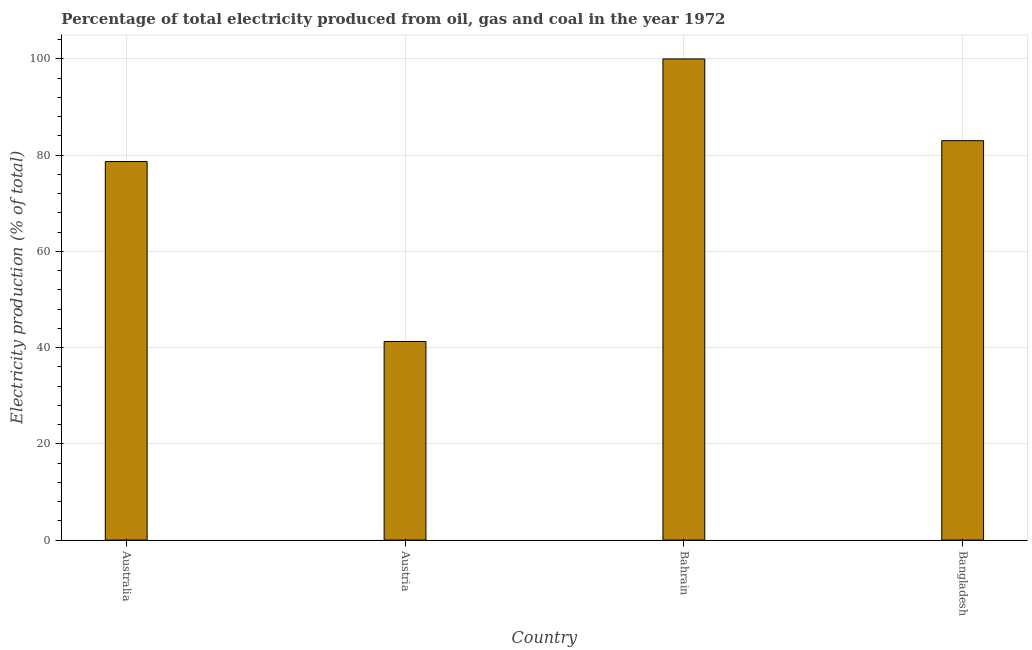Does the graph contain any zero values?
Offer a terse response. No. Does the graph contain grids?
Keep it short and to the point. Yes. What is the title of the graph?
Give a very brief answer. Percentage of total electricity produced from oil, gas and coal in the year 1972. What is the label or title of the X-axis?
Your answer should be compact. Country. What is the label or title of the Y-axis?
Offer a very short reply. Electricity production (% of total). What is the electricity production in Australia?
Keep it short and to the point. 78.68. Across all countries, what is the minimum electricity production?
Your response must be concise. 41.28. In which country was the electricity production maximum?
Offer a terse response. Bahrain. What is the sum of the electricity production?
Your answer should be compact. 302.96. What is the difference between the electricity production in Australia and Austria?
Keep it short and to the point. 37.4. What is the average electricity production per country?
Provide a succinct answer. 75.74. What is the median electricity production?
Ensure brevity in your answer.  80.84. In how many countries, is the electricity production greater than 96 %?
Keep it short and to the point. 1. What is the ratio of the electricity production in Austria to that in Bangladesh?
Offer a terse response. 0.5. What is the difference between the highest and the second highest electricity production?
Keep it short and to the point. 16.99. What is the difference between the highest and the lowest electricity production?
Your answer should be compact. 58.72. Are all the bars in the graph horizontal?
Your answer should be compact. No. Are the values on the major ticks of Y-axis written in scientific E-notation?
Your answer should be compact. No. What is the Electricity production (% of total) of Australia?
Provide a succinct answer. 78.68. What is the Electricity production (% of total) of Austria?
Give a very brief answer. 41.28. What is the Electricity production (% of total) of Bangladesh?
Keep it short and to the point. 83.01. What is the difference between the Electricity production (% of total) in Australia and Austria?
Offer a terse response. 37.4. What is the difference between the Electricity production (% of total) in Australia and Bahrain?
Provide a short and direct response. -21.32. What is the difference between the Electricity production (% of total) in Australia and Bangladesh?
Offer a very short reply. -4.33. What is the difference between the Electricity production (% of total) in Austria and Bahrain?
Your response must be concise. -58.72. What is the difference between the Electricity production (% of total) in Austria and Bangladesh?
Offer a terse response. -41.73. What is the difference between the Electricity production (% of total) in Bahrain and Bangladesh?
Give a very brief answer. 16.99. What is the ratio of the Electricity production (% of total) in Australia to that in Austria?
Keep it short and to the point. 1.91. What is the ratio of the Electricity production (% of total) in Australia to that in Bahrain?
Make the answer very short. 0.79. What is the ratio of the Electricity production (% of total) in Australia to that in Bangladesh?
Make the answer very short. 0.95. What is the ratio of the Electricity production (% of total) in Austria to that in Bahrain?
Keep it short and to the point. 0.41. What is the ratio of the Electricity production (% of total) in Austria to that in Bangladesh?
Offer a very short reply. 0.5. What is the ratio of the Electricity production (% of total) in Bahrain to that in Bangladesh?
Offer a very short reply. 1.21. 